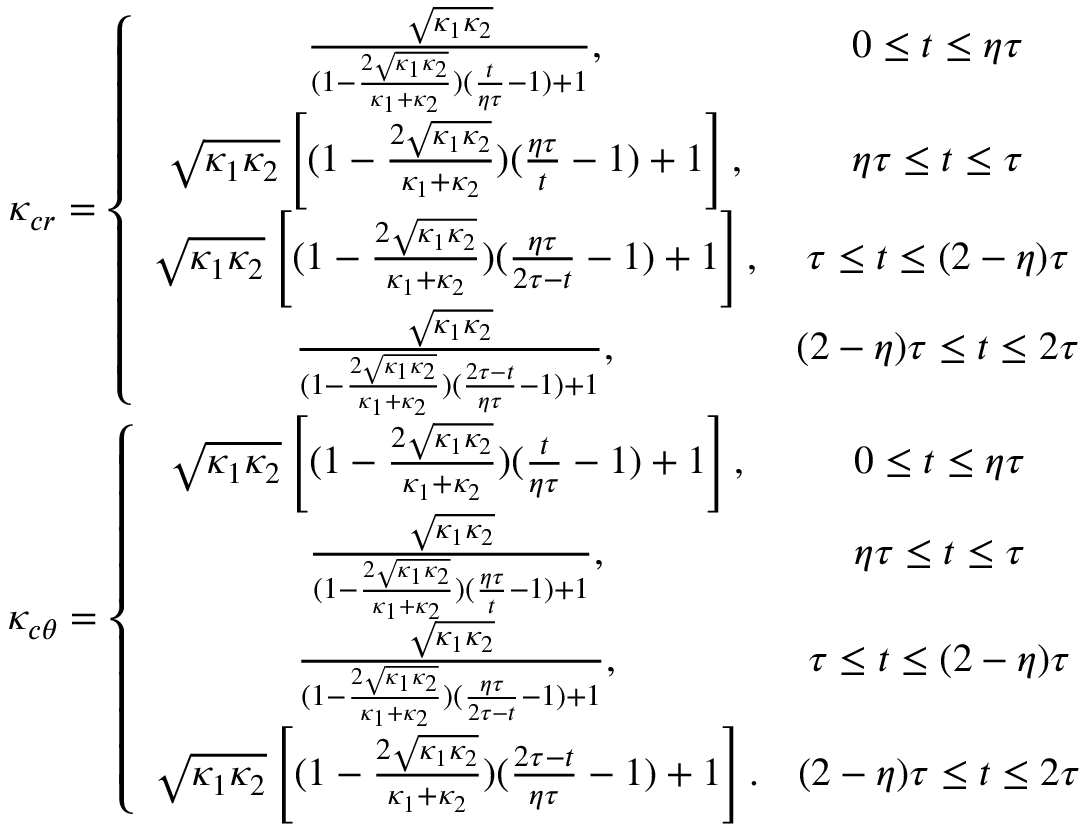<formula> <loc_0><loc_0><loc_500><loc_500>\begin{array} { c } { \kappa _ { c r } = \left \{ \begin{array} { c c } { \frac { \sqrt { \kappa _ { 1 } \kappa _ { 2 } } } { ( 1 - \frac { 2 \sqrt { \kappa _ { 1 } \kappa _ { 2 } } } { \kappa _ { 1 } + \kappa _ { 2 } } ) ( \frac { t } { \eta \tau } - 1 ) + 1 } , } & { 0 \leq t \leq \eta \tau } \\ { \sqrt { \kappa _ { 1 } \kappa _ { 2 } } \left [ ( 1 - \frac { 2 \sqrt { \kappa _ { 1 } \kappa _ { 2 } } } { \kappa _ { 1 } + \kappa _ { 2 } } ) ( \frac { \eta \tau } { t } - 1 ) + 1 \right ] , } & { \eta \tau \leq t \leq \tau } \\ { \sqrt { \kappa _ { 1 } \kappa _ { 2 } } \left [ ( 1 - \frac { 2 \sqrt { \kappa _ { 1 } \kappa _ { 2 } } } { \kappa _ { 1 } + \kappa _ { 2 } } ) ( \frac { \eta \tau } { 2 \tau - t } - 1 ) + 1 \right ] , } & { \tau \leq t \leq ( 2 - \eta ) \tau } \\ { \frac { \sqrt { \kappa _ { 1 } \kappa _ { 2 } } } { ( 1 - \frac { 2 \sqrt { \kappa _ { 1 } \kappa _ { 2 } } } { \kappa _ { 1 } + \kappa _ { 2 } } ) ( \frac { 2 \tau - t } { \eta \tau } - 1 ) + 1 } , } & { ( 2 - \eta ) \tau \leq t \leq 2 \tau } \end{array} } \\ { \kappa _ { c \theta } = \left \{ \begin{array} { c c } { \sqrt { \kappa _ { 1 } \kappa _ { 2 } } \left [ ( 1 - \frac { 2 \sqrt { \kappa _ { 1 } \kappa _ { 2 } } } { \kappa _ { 1 } + \kappa _ { 2 } } ) ( \frac { t } { \eta \tau } - 1 ) + 1 \right ] , } & { 0 \leq t \leq \eta \tau } \\ { \frac { \sqrt { \kappa _ { 1 } \kappa _ { 2 } } } { ( 1 - \frac { 2 \sqrt { \kappa _ { 1 } \kappa _ { 2 } } } { \kappa _ { 1 } + \kappa _ { 2 } } ) ( \frac { \eta \tau } { t } - 1 ) + 1 } , } & { \eta \tau \leq t \leq \tau } \\ { \frac { \sqrt { \kappa _ { 1 } \kappa _ { 2 } } } { ( 1 - \frac { 2 \sqrt { \kappa _ { 1 } \kappa _ { 2 } } } { \kappa _ { 1 } + \kappa _ { 2 } } ) ( \frac { \eta \tau } { 2 \tau - t } - 1 ) + 1 } , } & { \tau \leq t \leq ( 2 - \eta ) \tau } \\ { \sqrt { \kappa _ { 1 } \kappa _ { 2 } } \left [ ( 1 - \frac { 2 \sqrt { \kappa _ { 1 } \kappa _ { 2 } } } { \kappa _ { 1 } + \kappa _ { 2 } } ) ( \frac { 2 \tau - t } { \eta \tau } - 1 ) + 1 \right ] . } & { ( 2 - \eta ) \tau \leq t \leq 2 \tau } \end{array} } \end{array}</formula> 